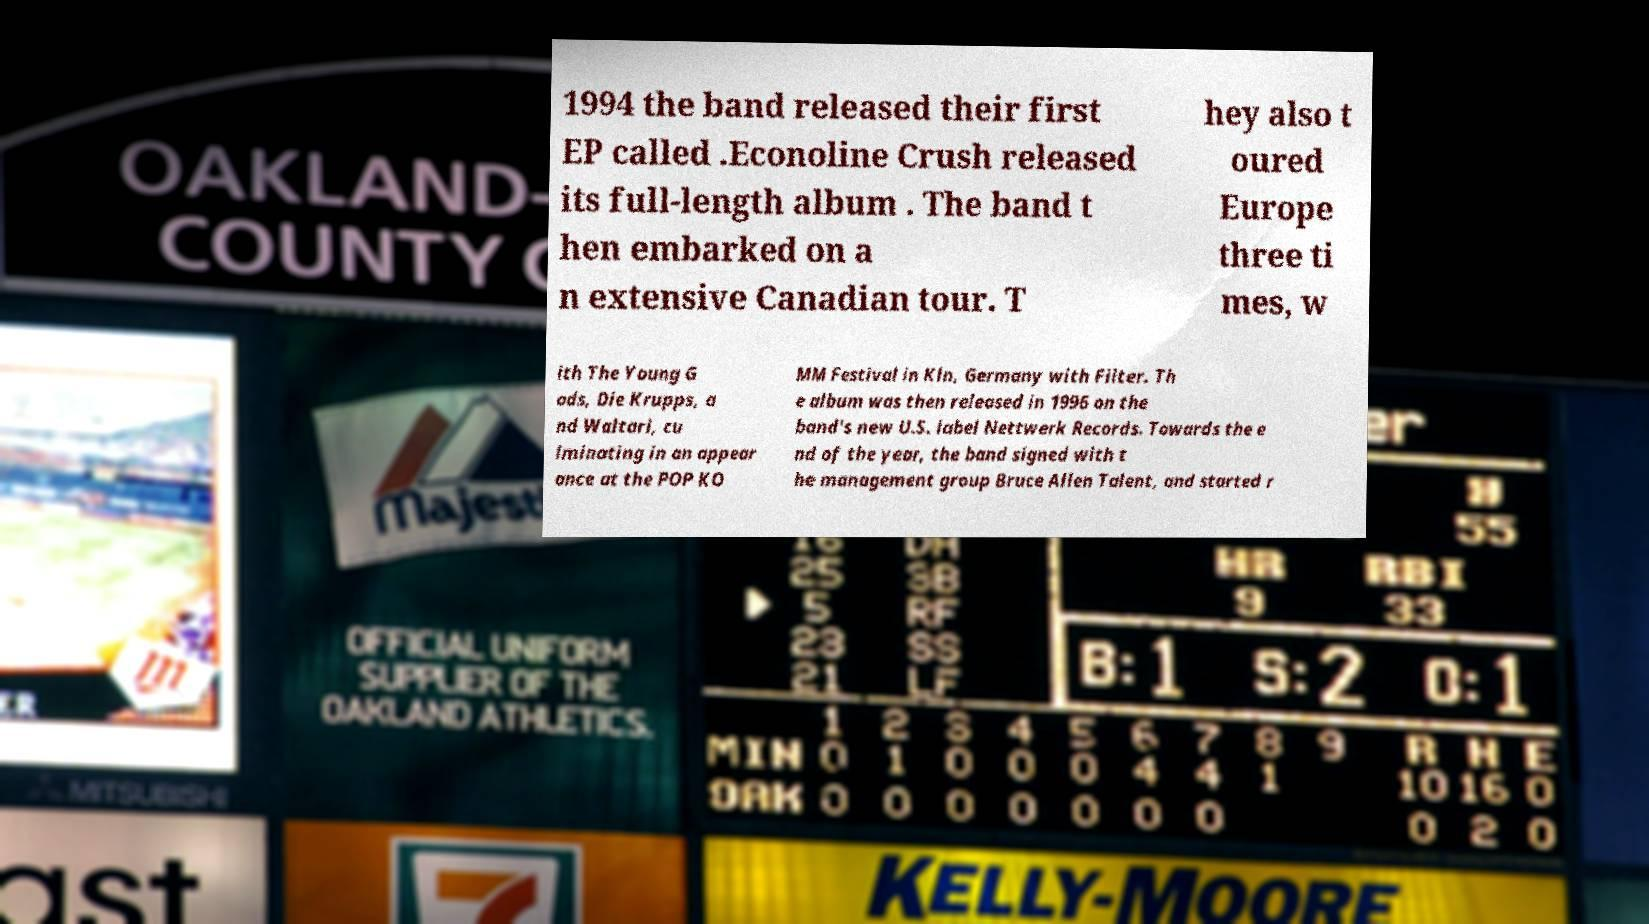Could you extract and type out the text from this image? 1994 the band released their first EP called .Econoline Crush released its full-length album . The band t hen embarked on a n extensive Canadian tour. T hey also t oured Europe three ti mes, w ith The Young G ods, Die Krupps, a nd Waltari, cu lminating in an appear ance at the POP KO MM Festival in Kln, Germany with Filter. Th e album was then released in 1996 on the band's new U.S. label Nettwerk Records. Towards the e nd of the year, the band signed with t he management group Bruce Allen Talent, and started r 